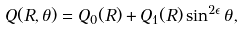Convert formula to latex. <formula><loc_0><loc_0><loc_500><loc_500>Q ( R , \theta ) = Q _ { 0 } ( R ) + Q _ { 1 } ( R ) \sin ^ { 2 \epsilon } \theta ,</formula> 